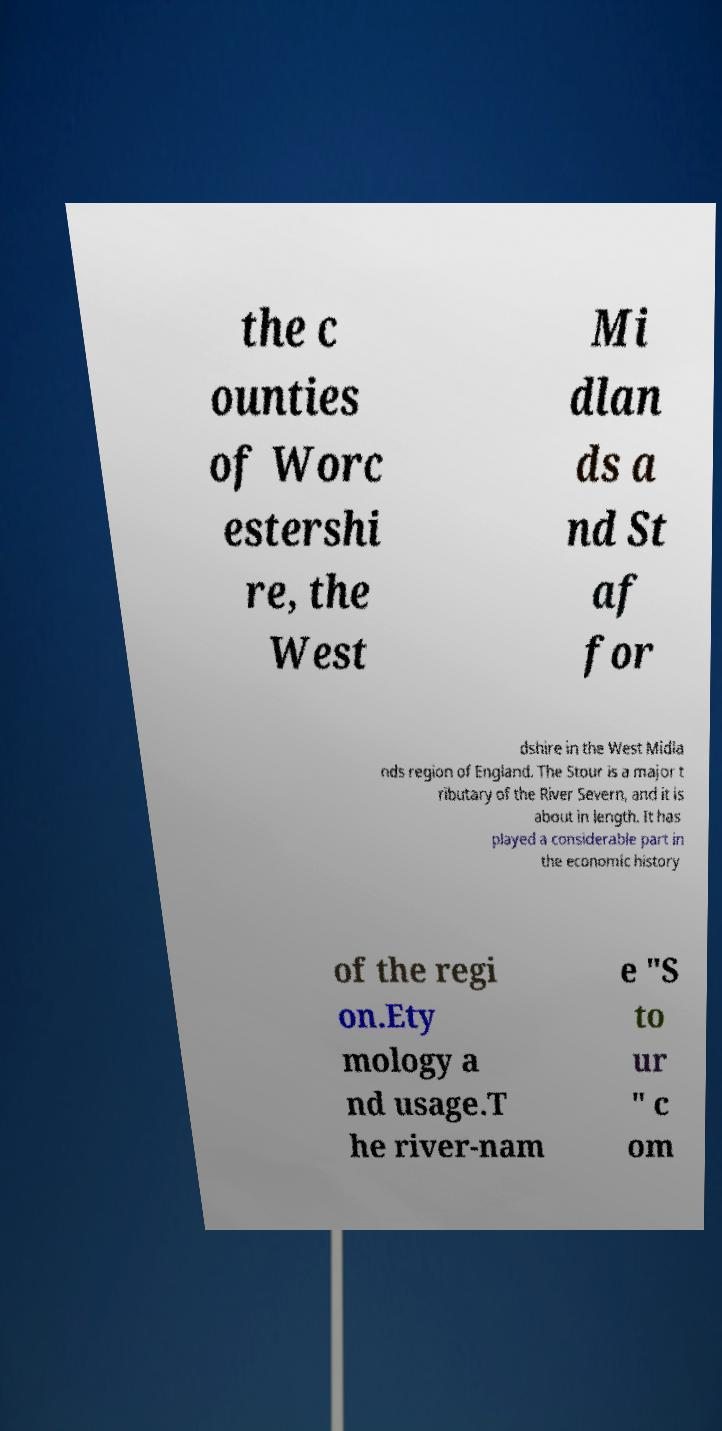For documentation purposes, I need the text within this image transcribed. Could you provide that? the c ounties of Worc estershi re, the West Mi dlan ds a nd St af for dshire in the West Midla nds region of England. The Stour is a major t ributary of the River Severn, and it is about in length. It has played a considerable part in the economic history of the regi on.Ety mology a nd usage.T he river-nam e "S to ur " c om 